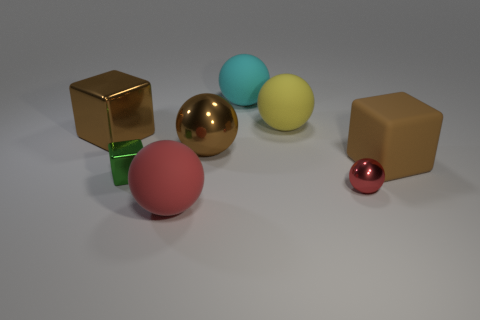Subtract all red balls. How many were subtracted if there are1red balls left? 1 Subtract all brown spheres. How many spheres are left? 4 Subtract all tiny metallic spheres. How many spheres are left? 4 Subtract 2 spheres. How many spheres are left? 3 Subtract all gray balls. Subtract all yellow cubes. How many balls are left? 5 Add 2 yellow rubber blocks. How many objects exist? 10 Subtract all blocks. How many objects are left? 5 Subtract 0 yellow cubes. How many objects are left? 8 Subtract all large green rubber cylinders. Subtract all big cyan spheres. How many objects are left? 7 Add 5 green metallic blocks. How many green metallic blocks are left? 6 